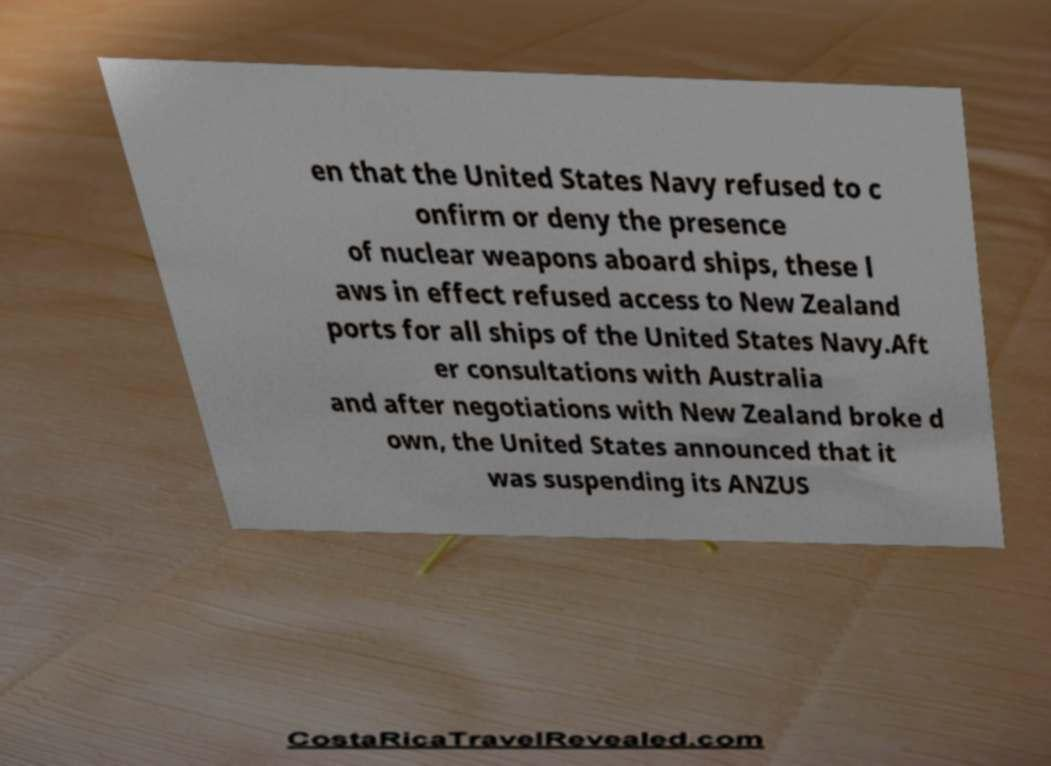Could you assist in decoding the text presented in this image and type it out clearly? en that the United States Navy refused to c onfirm or deny the presence of nuclear weapons aboard ships, these l aws in effect refused access to New Zealand ports for all ships of the United States Navy.Aft er consultations with Australia and after negotiations with New Zealand broke d own, the United States announced that it was suspending its ANZUS 